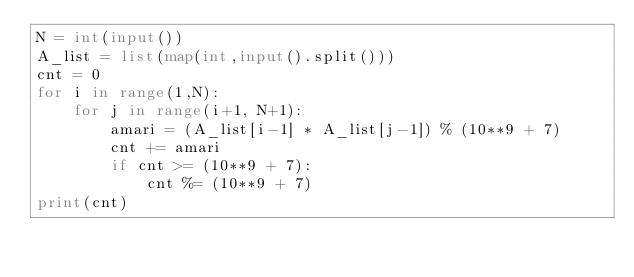<code> <loc_0><loc_0><loc_500><loc_500><_Python_>N = int(input())
A_list = list(map(int,input().split()))
cnt = 0
for i in range(1,N):
    for j in range(i+1, N+1):
        amari = (A_list[i-1] * A_list[j-1]) % (10**9 + 7) 
        cnt += amari
        if cnt >= (10**9 + 7):
            cnt %= (10**9 + 7)
print(cnt)</code> 